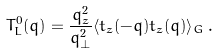<formula> <loc_0><loc_0><loc_500><loc_500>T ^ { 0 } _ { L } ( { q } ) = \frac { q _ { z } ^ { 2 } } { q _ { \perp } ^ { 2 } } \langle t _ { z } ( - { q } ) t _ { z } ( { q } ) \rangle _ { G } \, .</formula> 